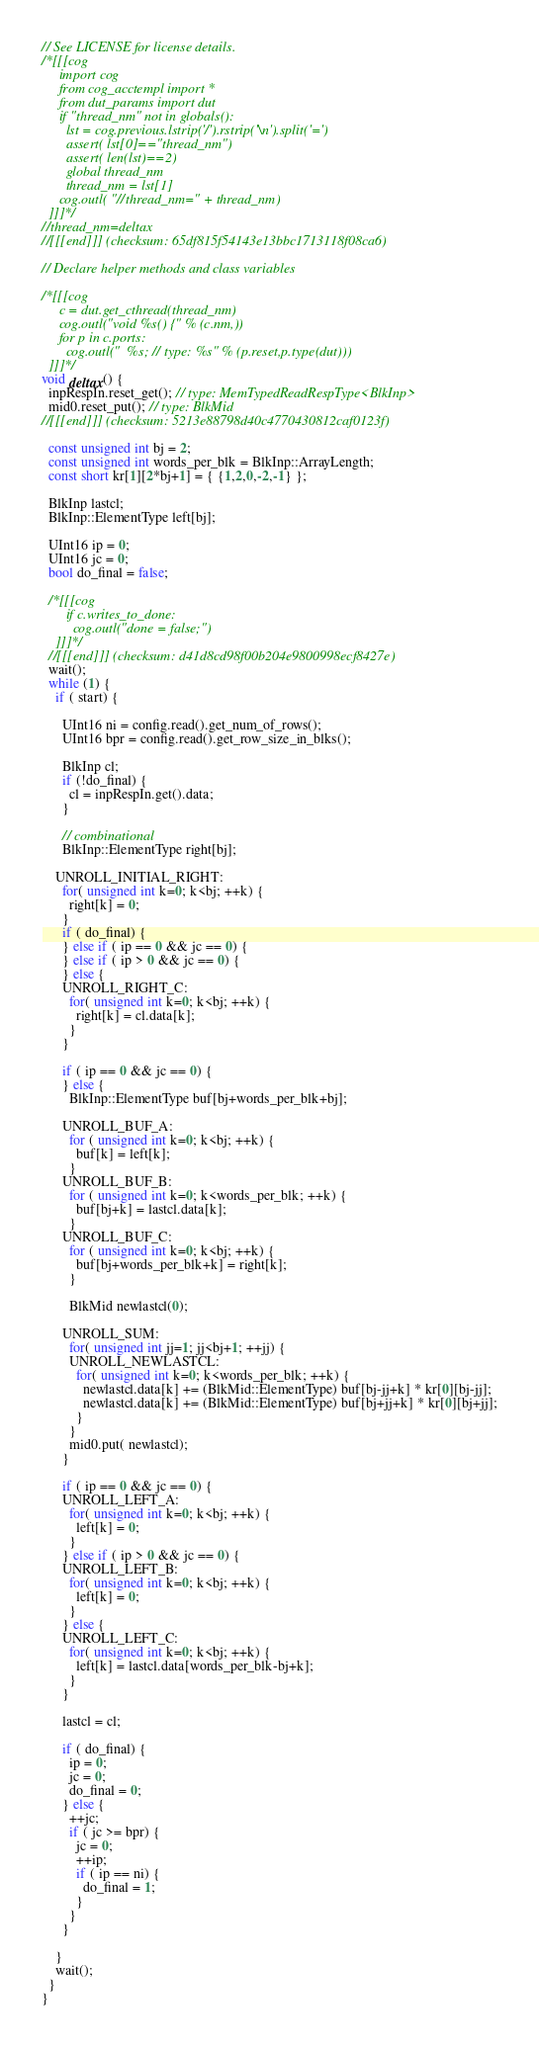<code> <loc_0><loc_0><loc_500><loc_500><_C_>// See LICENSE for license details.
/*[[[cog
     import cog
     from cog_acctempl import *
     from dut_params import dut
     if "thread_nm" not in globals():
       lst = cog.previous.lstrip('/').rstrip('\n').split('=')
       assert( lst[0]=="thread_nm")
       assert( len(lst)==2)
       global thread_nm
       thread_nm = lst[1]
     cog.outl( "//thread_nm=" + thread_nm)
  ]]]*/
//thread_nm=deltax
//[[[end]]] (checksum: 65df815f54143e13bbc1713118f08ca6)

// Declare helper methods and class variables

/*[[[cog
     c = dut.get_cthread(thread_nm)
     cog.outl("void %s() {" % (c.nm,))
     for p in c.ports:
       cog.outl("  %s; // type: %s" % (p.reset,p.type(dut)))
  ]]]*/
void deltax() {
  inpRespIn.reset_get(); // type: MemTypedReadRespType<BlkInp>
  mid0.reset_put(); // type: BlkMid
//[[[end]]] (checksum: 5213e88798d40c4770430812caf0123f)

  const unsigned int bj = 2;
  const unsigned int words_per_blk = BlkInp::ArrayLength;
  const short kr[1][2*bj+1] = { {1,2,0,-2,-1} };

  BlkInp lastcl;
  BlkInp::ElementType left[bj];

  UInt16 ip = 0;
  UInt16 jc = 0;
  bool do_final = false;

  /*[[[cog
       if c.writes_to_done:
         cog.outl("done = false;")
    ]]]*/
  //[[[end]]] (checksum: d41d8cd98f00b204e9800998ecf8427e)
  wait();
  while (1) {
    if ( start) {

      UInt16 ni = config.read().get_num_of_rows();
      UInt16 bpr = config.read().get_row_size_in_blks();

      BlkInp cl;
      if (!do_final) {
        cl = inpRespIn.get().data;
      }

      // combinational
      BlkInp::ElementType right[bj];

    UNROLL_INITIAL_RIGHT:
      for( unsigned int k=0; k<bj; ++k) {
        right[k] = 0;
      }
      if ( do_final) {
      } else if ( ip == 0 && jc == 0) {
      } else if ( ip > 0 && jc == 0) {
      } else {
      UNROLL_RIGHT_C:
        for( unsigned int k=0; k<bj; ++k) {
          right[k] = cl.data[k];
        }
      }

      if ( ip == 0 && jc == 0) {
      } else {
        BlkInp::ElementType buf[bj+words_per_blk+bj];

      UNROLL_BUF_A:
        for ( unsigned int k=0; k<bj; ++k) {
          buf[k] = left[k];
        }
      UNROLL_BUF_B:
        for ( unsigned int k=0; k<words_per_blk; ++k) {
          buf[bj+k] = lastcl.data[k];
        }
      UNROLL_BUF_C:
        for ( unsigned int k=0; k<bj; ++k) {
          buf[bj+words_per_blk+k] = right[k];
        }

        BlkMid newlastcl(0);

      UNROLL_SUM:
        for( unsigned int jj=1; jj<bj+1; ++jj) {
        UNROLL_NEWLASTCL:
          for( unsigned int k=0; k<words_per_blk; ++k) {
            newlastcl.data[k] += (BlkMid::ElementType) buf[bj-jj+k] * kr[0][bj-jj];
            newlastcl.data[k] += (BlkMid::ElementType) buf[bj+jj+k] * kr[0][bj+jj];
          }
        }
        mid0.put( newlastcl);      
      }

      if ( ip == 0 && jc == 0) {
      UNROLL_LEFT_A:
        for( unsigned int k=0; k<bj; ++k) {
          left[k] = 0;
        }
      } else if ( ip > 0 && jc == 0) {
      UNROLL_LEFT_B:
        for( unsigned int k=0; k<bj; ++k) {
          left[k] = 0;
        }
      } else {
      UNROLL_LEFT_C:
        for( unsigned int k=0; k<bj; ++k) {
          left[k] = lastcl.data[words_per_blk-bj+k];
        }
      }

      lastcl = cl;

      if ( do_final) {
        ip = 0;
        jc = 0;
        do_final = 0;
      } else {
        ++jc;
        if ( jc >= bpr) {
          jc = 0;
          ++ip;
          if ( ip == ni) {
            do_final = 1;
          }
        }
      }

    }
    wait();
  }
}
</code> 